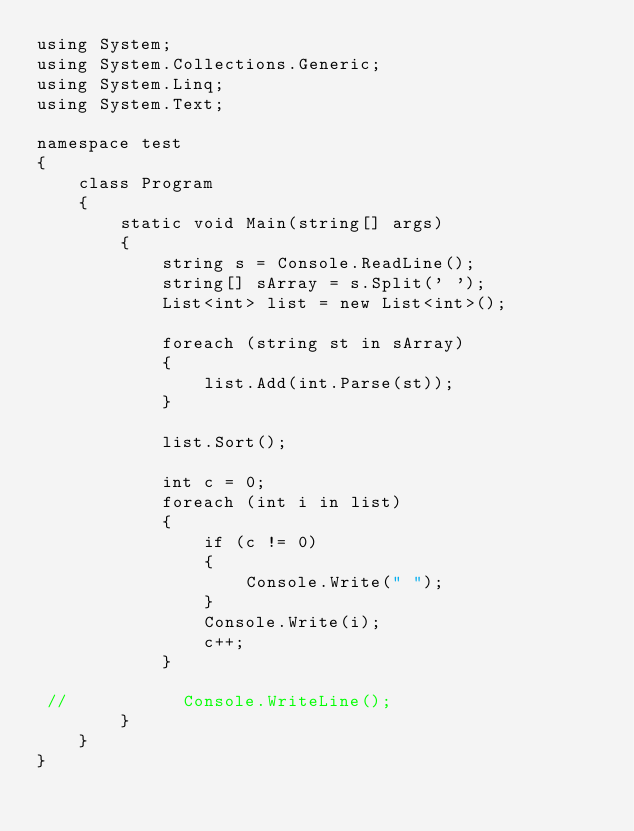Convert code to text. <code><loc_0><loc_0><loc_500><loc_500><_C#_>using System;
using System.Collections.Generic;
using System.Linq;
using System.Text;
 
namespace test
{
    class Program
    {
        static void Main(string[] args)
        {
            string s = Console.ReadLine();
            string[] sArray = s.Split(' ');
            List<int> list = new List<int>();
 
            foreach (string st in sArray)
            {
                list.Add(int.Parse(st));
            }
 
            list.Sort();
 
            int c = 0;
            foreach (int i in list)
            {
                if (c != 0)
                {
                    Console.Write(" ");
                }
                Console.Write(i);
                c++;
            }
 
 //           Console.WriteLine();
        }
    }
}</code> 